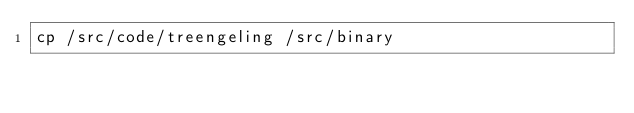<code> <loc_0><loc_0><loc_500><loc_500><_Bash_>cp /src/code/treengeling /src/binary
</code> 